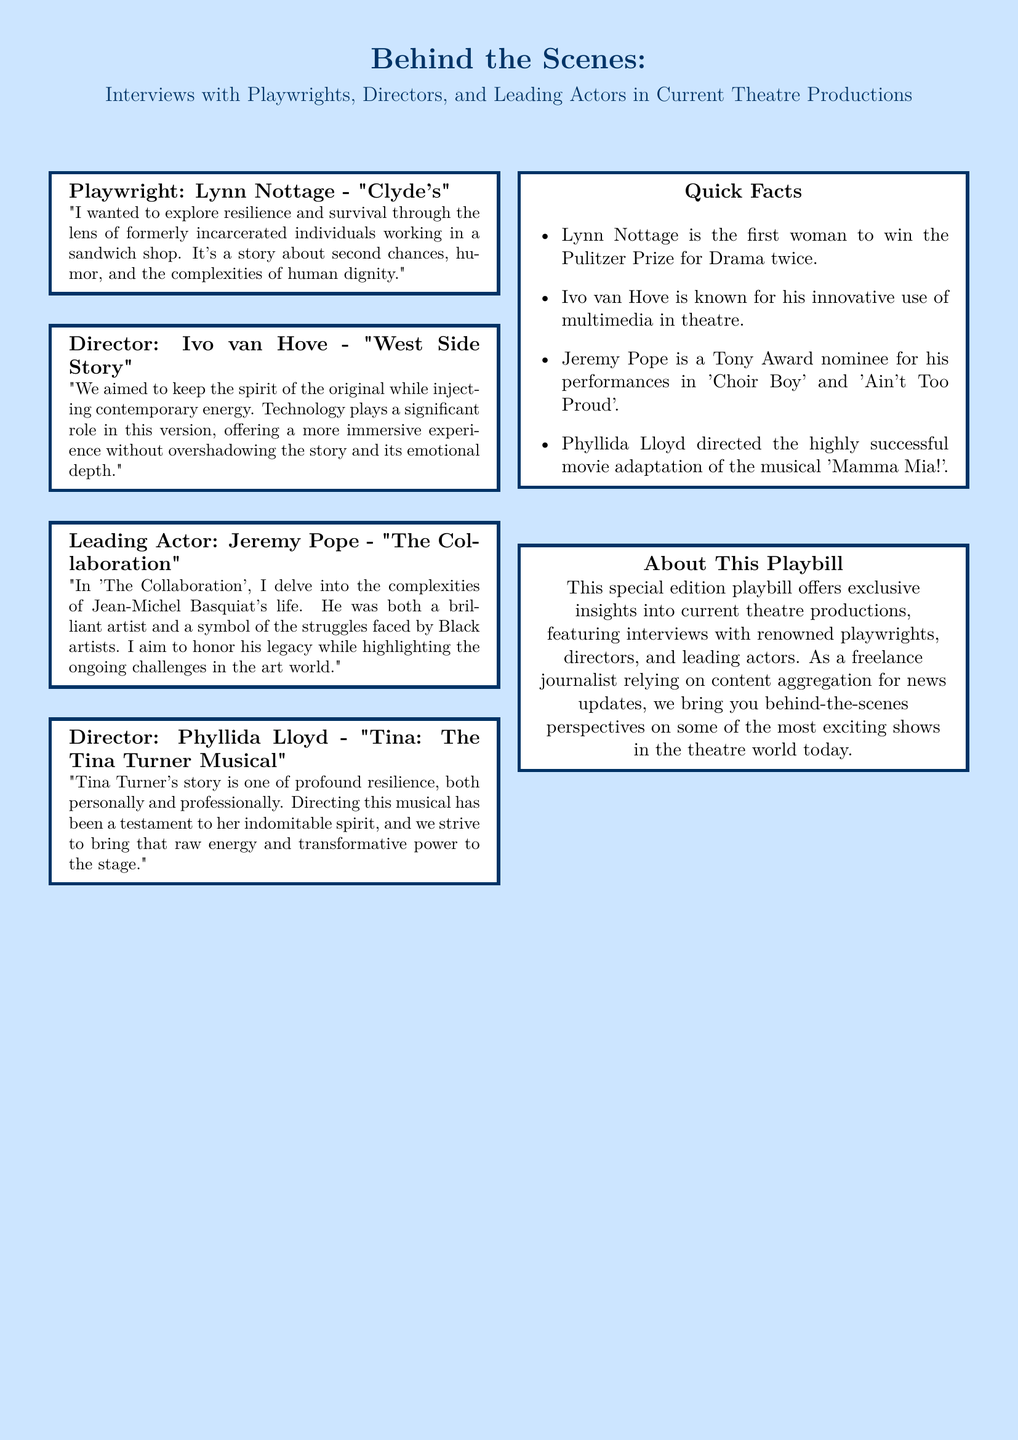What is the title of Lynn Nottage's play? The document explicitly mentions the play title "Clyde's" by Lynn Nottage.
Answer: Clyde's Who directed "West Side Story"? The director of "West Side Story" is identified as Ivo van Hove in the document.
Answer: Ivo van Hove What major theme does Lynn Nottage explore in "Clyde's"? The document notes that Nottage explores "resilience and survival" in "Clyde's."
Answer: resilience and survival Which actor portrays Jean-Michel Basquiat in "The Collaboration"? The document states that Jeremy Pope is the leading actor portraying Basquiat.
Answer: Jeremy Pope How many times has Lynn Nottage won the Pulitzer Prize for Drama? The document specifies that Lynn Nottage is the first woman to win the Pulitzer Prize for Drama twice.
Answer: twice What innovative element is Ivo van Hove known for in his direction? The document mentions that Ivo van Hove is known for his "innovative use of multimedia" in theatre.
Answer: innovative use of multimedia What is the focus of this special edition playbill? The document explains that the focus is on providing "exclusive insights into current theatre productions."
Answer: exclusive insights into current theatre productions Who directed "Tina: The Tina Turner Musical"? The director of "Tina: The Tina Turner Musical" is credited as Phyllida Lloyd in the document.
Answer: Phyllida Lloyd What term describes Tina Turner's story according to Phyllida Lloyd? Phyllida Lloyd describes Tina Turner’s story as one of "profound resilience."
Answer: profound resilience 